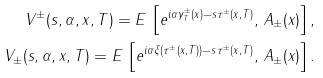Convert formula to latex. <formula><loc_0><loc_0><loc_500><loc_500>V ^ { \pm } ( s , \alpha , x , T ) = E \, \left [ e ^ { i \alpha \gamma ^ { \pm } _ { T } ( x ) - s \tau ^ { \pm } ( x , T ) } , \, A _ { \pm } ( x ) \right ] , \\ V _ { \pm } ( s , \alpha , x , T ) = E \, \left [ e ^ { i \alpha \xi ( \tau ^ { \pm } ( x , T ) ) - s \tau ^ { \pm } ( x , T ) } , \, A _ { \pm } ( x ) \right ] .</formula> 